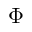Convert formula to latex. <formula><loc_0><loc_0><loc_500><loc_500>\Phi</formula> 